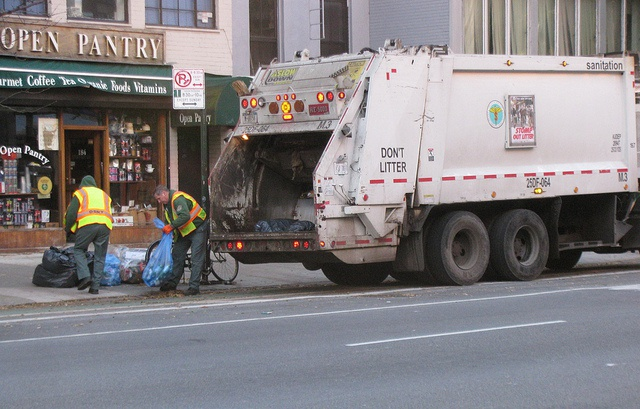Describe the objects in this image and their specific colors. I can see truck in gray, lightgray, black, and darkgray tones, people in gray, purple, black, and khaki tones, people in gray, black, purple, and brown tones, and bicycle in gray and black tones in this image. 